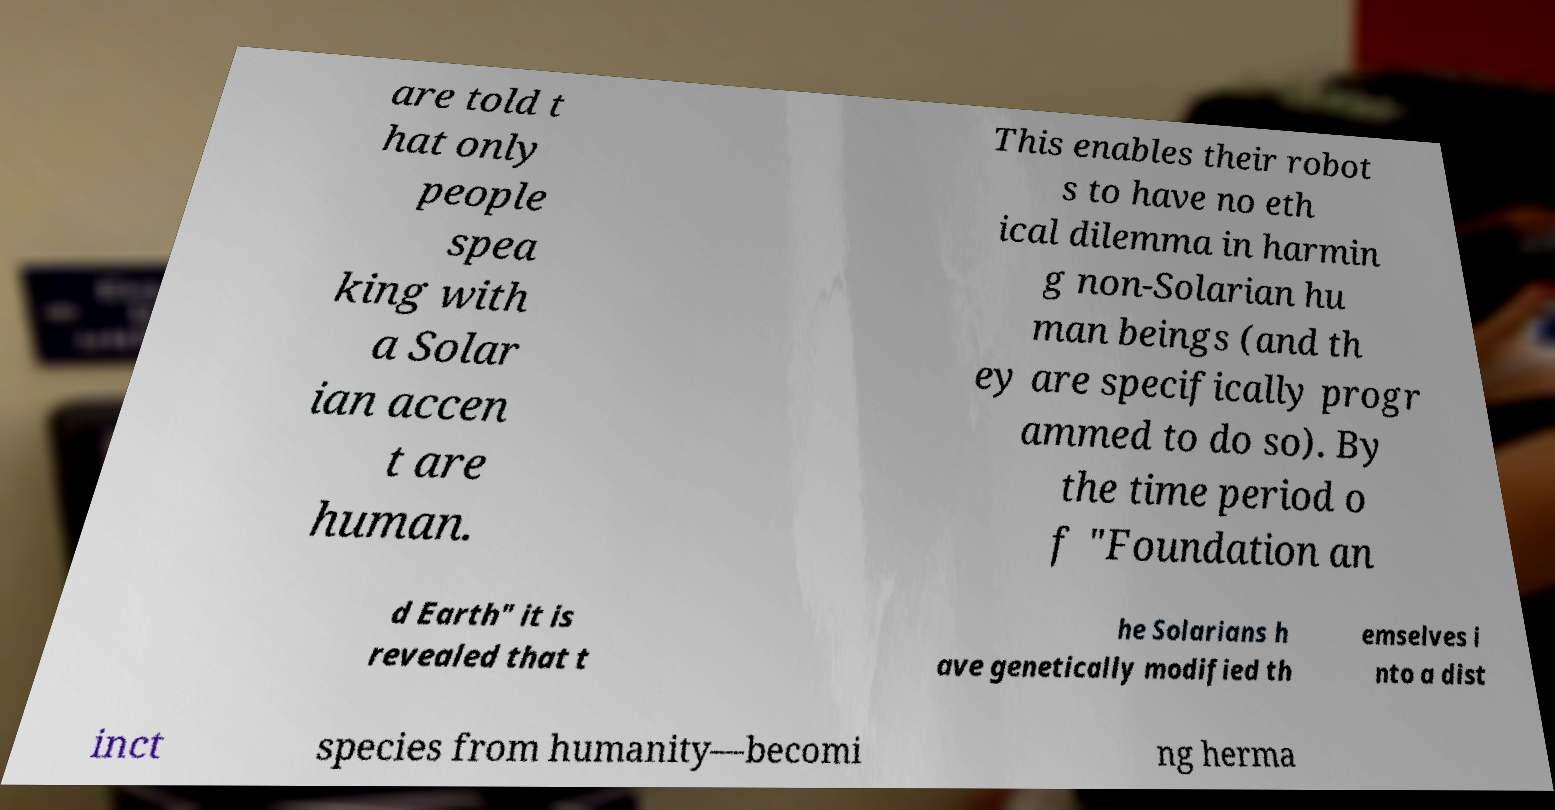Please identify and transcribe the text found in this image. are told t hat only people spea king with a Solar ian accen t are human. This enables their robot s to have no eth ical dilemma in harmin g non-Solarian hu man beings (and th ey are specifically progr ammed to do so). By the time period o f "Foundation an d Earth" it is revealed that t he Solarians h ave genetically modified th emselves i nto a dist inct species from humanity—becomi ng herma 